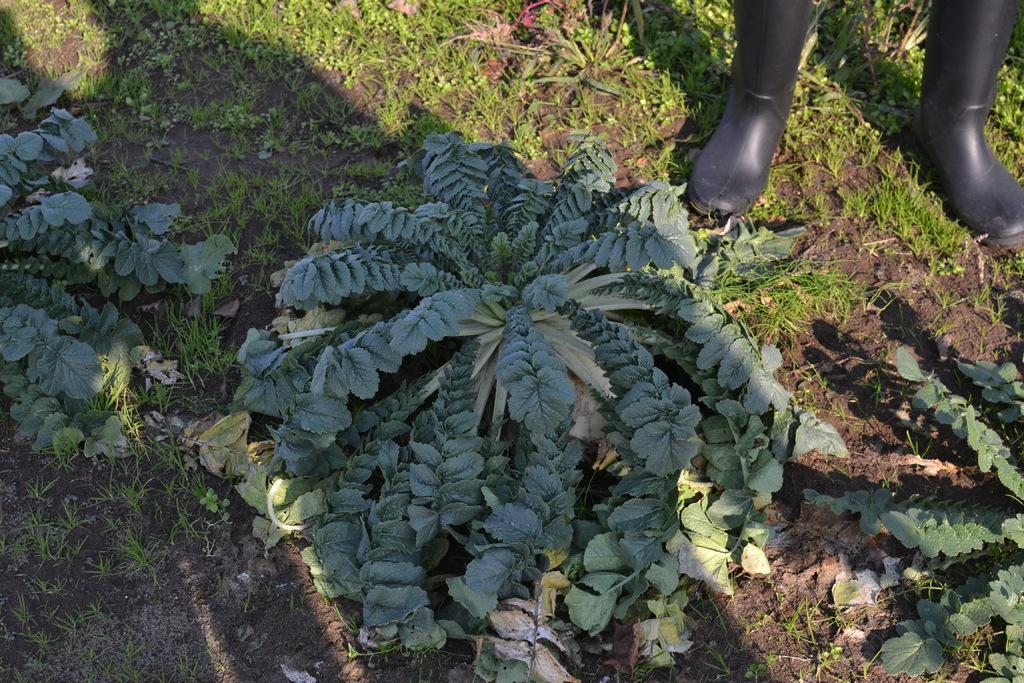Describe this image in one or two sentences. In this image we can see a pair of boots on the ground, shrubs and grass. 